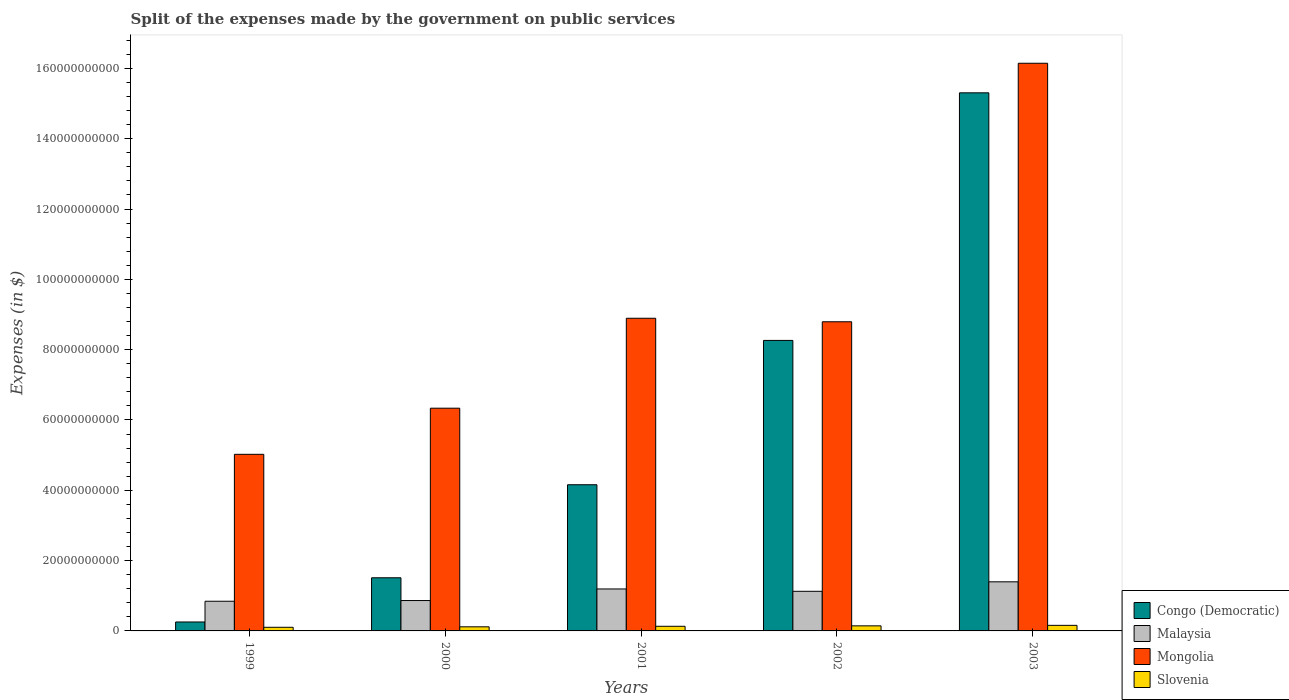How many different coloured bars are there?
Ensure brevity in your answer.  4. Are the number of bars per tick equal to the number of legend labels?
Keep it short and to the point. Yes. Are the number of bars on each tick of the X-axis equal?
Your answer should be very brief. Yes. How many bars are there on the 1st tick from the left?
Your answer should be very brief. 4. How many bars are there on the 1st tick from the right?
Ensure brevity in your answer.  4. What is the expenses made by the government on public services in Slovenia in 1999?
Offer a very short reply. 1.03e+09. Across all years, what is the maximum expenses made by the government on public services in Slovenia?
Keep it short and to the point. 1.58e+09. Across all years, what is the minimum expenses made by the government on public services in Congo (Democratic)?
Your answer should be compact. 2.54e+09. In which year was the expenses made by the government on public services in Slovenia maximum?
Offer a terse response. 2003. In which year was the expenses made by the government on public services in Congo (Democratic) minimum?
Offer a terse response. 1999. What is the total expenses made by the government on public services in Congo (Democratic) in the graph?
Your answer should be compact. 2.95e+11. What is the difference between the expenses made by the government on public services in Malaysia in 2002 and that in 2003?
Your response must be concise. -2.70e+09. What is the difference between the expenses made by the government on public services in Mongolia in 2000 and the expenses made by the government on public services in Slovenia in 2002?
Your response must be concise. 6.19e+1. What is the average expenses made by the government on public services in Slovenia per year?
Provide a succinct answer. 1.31e+09. In the year 1999, what is the difference between the expenses made by the government on public services in Malaysia and expenses made by the government on public services in Congo (Democratic)?
Offer a terse response. 5.90e+09. What is the ratio of the expenses made by the government on public services in Malaysia in 2002 to that in 2003?
Ensure brevity in your answer.  0.81. Is the expenses made by the government on public services in Malaysia in 1999 less than that in 2003?
Keep it short and to the point. Yes. Is the difference between the expenses made by the government on public services in Malaysia in 2000 and 2003 greater than the difference between the expenses made by the government on public services in Congo (Democratic) in 2000 and 2003?
Your response must be concise. Yes. What is the difference between the highest and the second highest expenses made by the government on public services in Malaysia?
Make the answer very short. 2.03e+09. What is the difference between the highest and the lowest expenses made by the government on public services in Mongolia?
Your response must be concise. 1.11e+11. In how many years, is the expenses made by the government on public services in Mongolia greater than the average expenses made by the government on public services in Mongolia taken over all years?
Offer a terse response. 1. What does the 4th bar from the left in 2002 represents?
Offer a very short reply. Slovenia. What does the 2nd bar from the right in 2003 represents?
Give a very brief answer. Mongolia. Is it the case that in every year, the sum of the expenses made by the government on public services in Malaysia and expenses made by the government on public services in Mongolia is greater than the expenses made by the government on public services in Slovenia?
Provide a short and direct response. Yes. How many bars are there?
Ensure brevity in your answer.  20. Are all the bars in the graph horizontal?
Your response must be concise. No. How many years are there in the graph?
Provide a short and direct response. 5. Does the graph contain any zero values?
Make the answer very short. No. Does the graph contain grids?
Make the answer very short. No. Where does the legend appear in the graph?
Offer a very short reply. Bottom right. How are the legend labels stacked?
Your answer should be very brief. Vertical. What is the title of the graph?
Ensure brevity in your answer.  Split of the expenses made by the government on public services. Does "Malta" appear as one of the legend labels in the graph?
Ensure brevity in your answer.  No. What is the label or title of the X-axis?
Provide a succinct answer. Years. What is the label or title of the Y-axis?
Offer a very short reply. Expenses (in $). What is the Expenses (in $) of Congo (Democratic) in 1999?
Ensure brevity in your answer.  2.54e+09. What is the Expenses (in $) in Malaysia in 1999?
Ensure brevity in your answer.  8.44e+09. What is the Expenses (in $) in Mongolia in 1999?
Your answer should be compact. 5.02e+1. What is the Expenses (in $) in Slovenia in 1999?
Your answer should be very brief. 1.03e+09. What is the Expenses (in $) of Congo (Democratic) in 2000?
Make the answer very short. 1.51e+1. What is the Expenses (in $) of Malaysia in 2000?
Provide a succinct answer. 8.64e+09. What is the Expenses (in $) of Mongolia in 2000?
Ensure brevity in your answer.  6.34e+1. What is the Expenses (in $) of Slovenia in 2000?
Ensure brevity in your answer.  1.17e+09. What is the Expenses (in $) in Congo (Democratic) in 2001?
Offer a terse response. 4.16e+1. What is the Expenses (in $) of Malaysia in 2001?
Your answer should be compact. 1.19e+1. What is the Expenses (in $) of Mongolia in 2001?
Keep it short and to the point. 8.89e+1. What is the Expenses (in $) of Slovenia in 2001?
Provide a succinct answer. 1.32e+09. What is the Expenses (in $) of Congo (Democratic) in 2002?
Your answer should be very brief. 8.26e+1. What is the Expenses (in $) in Malaysia in 2002?
Your answer should be very brief. 1.13e+1. What is the Expenses (in $) of Mongolia in 2002?
Your answer should be very brief. 8.79e+1. What is the Expenses (in $) of Slovenia in 2002?
Your answer should be compact. 1.44e+09. What is the Expenses (in $) of Congo (Democratic) in 2003?
Offer a very short reply. 1.53e+11. What is the Expenses (in $) in Malaysia in 2003?
Give a very brief answer. 1.40e+1. What is the Expenses (in $) in Mongolia in 2003?
Ensure brevity in your answer.  1.61e+11. What is the Expenses (in $) in Slovenia in 2003?
Offer a terse response. 1.58e+09. Across all years, what is the maximum Expenses (in $) of Congo (Democratic)?
Your answer should be very brief. 1.53e+11. Across all years, what is the maximum Expenses (in $) of Malaysia?
Your answer should be very brief. 1.40e+1. Across all years, what is the maximum Expenses (in $) in Mongolia?
Your answer should be very brief. 1.61e+11. Across all years, what is the maximum Expenses (in $) in Slovenia?
Your response must be concise. 1.58e+09. Across all years, what is the minimum Expenses (in $) in Congo (Democratic)?
Your answer should be compact. 2.54e+09. Across all years, what is the minimum Expenses (in $) of Malaysia?
Give a very brief answer. 8.44e+09. Across all years, what is the minimum Expenses (in $) in Mongolia?
Offer a very short reply. 5.02e+1. Across all years, what is the minimum Expenses (in $) in Slovenia?
Your answer should be very brief. 1.03e+09. What is the total Expenses (in $) in Congo (Democratic) in the graph?
Give a very brief answer. 2.95e+11. What is the total Expenses (in $) of Malaysia in the graph?
Ensure brevity in your answer.  5.43e+1. What is the total Expenses (in $) in Mongolia in the graph?
Your response must be concise. 4.52e+11. What is the total Expenses (in $) in Slovenia in the graph?
Your answer should be compact. 6.55e+09. What is the difference between the Expenses (in $) in Congo (Democratic) in 1999 and that in 2000?
Offer a terse response. -1.26e+1. What is the difference between the Expenses (in $) in Malaysia in 1999 and that in 2000?
Your response must be concise. -1.99e+08. What is the difference between the Expenses (in $) in Mongolia in 1999 and that in 2000?
Ensure brevity in your answer.  -1.31e+1. What is the difference between the Expenses (in $) of Slovenia in 1999 and that in 2000?
Your response must be concise. -1.32e+08. What is the difference between the Expenses (in $) in Congo (Democratic) in 1999 and that in 2001?
Your response must be concise. -3.90e+1. What is the difference between the Expenses (in $) of Malaysia in 1999 and that in 2001?
Offer a terse response. -3.49e+09. What is the difference between the Expenses (in $) in Mongolia in 1999 and that in 2001?
Offer a very short reply. -3.87e+1. What is the difference between the Expenses (in $) of Slovenia in 1999 and that in 2001?
Give a very brief answer. -2.86e+08. What is the difference between the Expenses (in $) of Congo (Democratic) in 1999 and that in 2002?
Your answer should be very brief. -8.01e+1. What is the difference between the Expenses (in $) in Malaysia in 1999 and that in 2002?
Your answer should be compact. -2.83e+09. What is the difference between the Expenses (in $) of Mongolia in 1999 and that in 2002?
Keep it short and to the point. -3.77e+1. What is the difference between the Expenses (in $) of Slovenia in 1999 and that in 2002?
Provide a succinct answer. -4.10e+08. What is the difference between the Expenses (in $) of Congo (Democratic) in 1999 and that in 2003?
Your answer should be compact. -1.51e+11. What is the difference between the Expenses (in $) in Malaysia in 1999 and that in 2003?
Ensure brevity in your answer.  -5.52e+09. What is the difference between the Expenses (in $) of Mongolia in 1999 and that in 2003?
Make the answer very short. -1.11e+11. What is the difference between the Expenses (in $) in Slovenia in 1999 and that in 2003?
Your answer should be very brief. -5.51e+08. What is the difference between the Expenses (in $) in Congo (Democratic) in 2000 and that in 2001?
Your response must be concise. -2.65e+1. What is the difference between the Expenses (in $) in Malaysia in 2000 and that in 2001?
Give a very brief answer. -3.29e+09. What is the difference between the Expenses (in $) of Mongolia in 2000 and that in 2001?
Offer a terse response. -2.56e+1. What is the difference between the Expenses (in $) of Slovenia in 2000 and that in 2001?
Make the answer very short. -1.53e+08. What is the difference between the Expenses (in $) of Congo (Democratic) in 2000 and that in 2002?
Provide a succinct answer. -6.75e+1. What is the difference between the Expenses (in $) in Malaysia in 2000 and that in 2002?
Offer a terse response. -2.63e+09. What is the difference between the Expenses (in $) in Mongolia in 2000 and that in 2002?
Give a very brief answer. -2.46e+1. What is the difference between the Expenses (in $) of Slovenia in 2000 and that in 2002?
Give a very brief answer. -2.78e+08. What is the difference between the Expenses (in $) in Congo (Democratic) in 2000 and that in 2003?
Provide a succinct answer. -1.38e+11. What is the difference between the Expenses (in $) in Malaysia in 2000 and that in 2003?
Provide a short and direct response. -5.33e+09. What is the difference between the Expenses (in $) of Mongolia in 2000 and that in 2003?
Provide a short and direct response. -9.81e+1. What is the difference between the Expenses (in $) of Slovenia in 2000 and that in 2003?
Provide a succinct answer. -4.19e+08. What is the difference between the Expenses (in $) in Congo (Democratic) in 2001 and that in 2002?
Your response must be concise. -4.11e+1. What is the difference between the Expenses (in $) of Malaysia in 2001 and that in 2002?
Give a very brief answer. 6.67e+08. What is the difference between the Expenses (in $) of Mongolia in 2001 and that in 2002?
Your answer should be very brief. 1.00e+09. What is the difference between the Expenses (in $) of Slovenia in 2001 and that in 2002?
Offer a terse response. -1.24e+08. What is the difference between the Expenses (in $) of Congo (Democratic) in 2001 and that in 2003?
Offer a terse response. -1.11e+11. What is the difference between the Expenses (in $) of Malaysia in 2001 and that in 2003?
Your answer should be very brief. -2.03e+09. What is the difference between the Expenses (in $) in Mongolia in 2001 and that in 2003?
Provide a short and direct response. -7.25e+1. What is the difference between the Expenses (in $) of Slovenia in 2001 and that in 2003?
Your answer should be very brief. -2.66e+08. What is the difference between the Expenses (in $) of Congo (Democratic) in 2002 and that in 2003?
Ensure brevity in your answer.  -7.04e+1. What is the difference between the Expenses (in $) in Malaysia in 2002 and that in 2003?
Provide a succinct answer. -2.70e+09. What is the difference between the Expenses (in $) in Mongolia in 2002 and that in 2003?
Offer a very short reply. -7.35e+1. What is the difference between the Expenses (in $) of Slovenia in 2002 and that in 2003?
Offer a terse response. -1.41e+08. What is the difference between the Expenses (in $) in Congo (Democratic) in 1999 and the Expenses (in $) in Malaysia in 2000?
Your answer should be compact. -6.10e+09. What is the difference between the Expenses (in $) of Congo (Democratic) in 1999 and the Expenses (in $) of Mongolia in 2000?
Your answer should be compact. -6.08e+1. What is the difference between the Expenses (in $) in Congo (Democratic) in 1999 and the Expenses (in $) in Slovenia in 2000?
Your answer should be very brief. 1.38e+09. What is the difference between the Expenses (in $) of Malaysia in 1999 and the Expenses (in $) of Mongolia in 2000?
Offer a very short reply. -5.49e+1. What is the difference between the Expenses (in $) in Malaysia in 1999 and the Expenses (in $) in Slovenia in 2000?
Give a very brief answer. 7.28e+09. What is the difference between the Expenses (in $) in Mongolia in 1999 and the Expenses (in $) in Slovenia in 2000?
Give a very brief answer. 4.91e+1. What is the difference between the Expenses (in $) of Congo (Democratic) in 1999 and the Expenses (in $) of Malaysia in 2001?
Keep it short and to the point. -9.39e+09. What is the difference between the Expenses (in $) in Congo (Democratic) in 1999 and the Expenses (in $) in Mongolia in 2001?
Offer a terse response. -8.64e+1. What is the difference between the Expenses (in $) in Congo (Democratic) in 1999 and the Expenses (in $) in Slovenia in 2001?
Provide a succinct answer. 1.22e+09. What is the difference between the Expenses (in $) of Malaysia in 1999 and the Expenses (in $) of Mongolia in 2001?
Ensure brevity in your answer.  -8.05e+1. What is the difference between the Expenses (in $) in Malaysia in 1999 and the Expenses (in $) in Slovenia in 2001?
Provide a short and direct response. 7.12e+09. What is the difference between the Expenses (in $) in Mongolia in 1999 and the Expenses (in $) in Slovenia in 2001?
Your answer should be compact. 4.89e+1. What is the difference between the Expenses (in $) of Congo (Democratic) in 1999 and the Expenses (in $) of Malaysia in 2002?
Ensure brevity in your answer.  -8.73e+09. What is the difference between the Expenses (in $) of Congo (Democratic) in 1999 and the Expenses (in $) of Mongolia in 2002?
Your answer should be very brief. -8.54e+1. What is the difference between the Expenses (in $) in Congo (Democratic) in 1999 and the Expenses (in $) in Slovenia in 2002?
Provide a short and direct response. 1.10e+09. What is the difference between the Expenses (in $) of Malaysia in 1999 and the Expenses (in $) of Mongolia in 2002?
Your response must be concise. -7.95e+1. What is the difference between the Expenses (in $) in Malaysia in 1999 and the Expenses (in $) in Slovenia in 2002?
Your response must be concise. 7.00e+09. What is the difference between the Expenses (in $) of Mongolia in 1999 and the Expenses (in $) of Slovenia in 2002?
Your answer should be compact. 4.88e+1. What is the difference between the Expenses (in $) of Congo (Democratic) in 1999 and the Expenses (in $) of Malaysia in 2003?
Ensure brevity in your answer.  -1.14e+1. What is the difference between the Expenses (in $) of Congo (Democratic) in 1999 and the Expenses (in $) of Mongolia in 2003?
Give a very brief answer. -1.59e+11. What is the difference between the Expenses (in $) of Congo (Democratic) in 1999 and the Expenses (in $) of Slovenia in 2003?
Make the answer very short. 9.58e+08. What is the difference between the Expenses (in $) in Malaysia in 1999 and the Expenses (in $) in Mongolia in 2003?
Provide a short and direct response. -1.53e+11. What is the difference between the Expenses (in $) of Malaysia in 1999 and the Expenses (in $) of Slovenia in 2003?
Your response must be concise. 6.86e+09. What is the difference between the Expenses (in $) of Mongolia in 1999 and the Expenses (in $) of Slovenia in 2003?
Offer a very short reply. 4.86e+1. What is the difference between the Expenses (in $) in Congo (Democratic) in 2000 and the Expenses (in $) in Malaysia in 2001?
Offer a very short reply. 3.18e+09. What is the difference between the Expenses (in $) in Congo (Democratic) in 2000 and the Expenses (in $) in Mongolia in 2001?
Your answer should be compact. -7.38e+1. What is the difference between the Expenses (in $) in Congo (Democratic) in 2000 and the Expenses (in $) in Slovenia in 2001?
Keep it short and to the point. 1.38e+1. What is the difference between the Expenses (in $) of Malaysia in 2000 and the Expenses (in $) of Mongolia in 2001?
Keep it short and to the point. -8.03e+1. What is the difference between the Expenses (in $) in Malaysia in 2000 and the Expenses (in $) in Slovenia in 2001?
Make the answer very short. 7.32e+09. What is the difference between the Expenses (in $) in Mongolia in 2000 and the Expenses (in $) in Slovenia in 2001?
Ensure brevity in your answer.  6.20e+1. What is the difference between the Expenses (in $) in Congo (Democratic) in 2000 and the Expenses (in $) in Malaysia in 2002?
Your answer should be very brief. 3.85e+09. What is the difference between the Expenses (in $) of Congo (Democratic) in 2000 and the Expenses (in $) of Mongolia in 2002?
Keep it short and to the point. -7.28e+1. What is the difference between the Expenses (in $) in Congo (Democratic) in 2000 and the Expenses (in $) in Slovenia in 2002?
Make the answer very short. 1.37e+1. What is the difference between the Expenses (in $) in Malaysia in 2000 and the Expenses (in $) in Mongolia in 2002?
Your answer should be very brief. -7.93e+1. What is the difference between the Expenses (in $) of Malaysia in 2000 and the Expenses (in $) of Slovenia in 2002?
Your response must be concise. 7.20e+09. What is the difference between the Expenses (in $) in Mongolia in 2000 and the Expenses (in $) in Slovenia in 2002?
Make the answer very short. 6.19e+1. What is the difference between the Expenses (in $) of Congo (Democratic) in 2000 and the Expenses (in $) of Malaysia in 2003?
Your answer should be compact. 1.15e+09. What is the difference between the Expenses (in $) in Congo (Democratic) in 2000 and the Expenses (in $) in Mongolia in 2003?
Provide a short and direct response. -1.46e+11. What is the difference between the Expenses (in $) of Congo (Democratic) in 2000 and the Expenses (in $) of Slovenia in 2003?
Your response must be concise. 1.35e+1. What is the difference between the Expenses (in $) of Malaysia in 2000 and the Expenses (in $) of Mongolia in 2003?
Offer a very short reply. -1.53e+11. What is the difference between the Expenses (in $) in Malaysia in 2000 and the Expenses (in $) in Slovenia in 2003?
Your answer should be compact. 7.06e+09. What is the difference between the Expenses (in $) of Mongolia in 2000 and the Expenses (in $) of Slovenia in 2003?
Give a very brief answer. 6.18e+1. What is the difference between the Expenses (in $) of Congo (Democratic) in 2001 and the Expenses (in $) of Malaysia in 2002?
Your answer should be very brief. 3.03e+1. What is the difference between the Expenses (in $) of Congo (Democratic) in 2001 and the Expenses (in $) of Mongolia in 2002?
Your response must be concise. -4.64e+1. What is the difference between the Expenses (in $) in Congo (Democratic) in 2001 and the Expenses (in $) in Slovenia in 2002?
Your answer should be very brief. 4.01e+1. What is the difference between the Expenses (in $) in Malaysia in 2001 and the Expenses (in $) in Mongolia in 2002?
Provide a short and direct response. -7.60e+1. What is the difference between the Expenses (in $) of Malaysia in 2001 and the Expenses (in $) of Slovenia in 2002?
Provide a short and direct response. 1.05e+1. What is the difference between the Expenses (in $) in Mongolia in 2001 and the Expenses (in $) in Slovenia in 2002?
Ensure brevity in your answer.  8.75e+1. What is the difference between the Expenses (in $) of Congo (Democratic) in 2001 and the Expenses (in $) of Malaysia in 2003?
Your answer should be very brief. 2.76e+1. What is the difference between the Expenses (in $) in Congo (Democratic) in 2001 and the Expenses (in $) in Mongolia in 2003?
Give a very brief answer. -1.20e+11. What is the difference between the Expenses (in $) in Congo (Democratic) in 2001 and the Expenses (in $) in Slovenia in 2003?
Your response must be concise. 4.00e+1. What is the difference between the Expenses (in $) of Malaysia in 2001 and the Expenses (in $) of Mongolia in 2003?
Provide a succinct answer. -1.50e+11. What is the difference between the Expenses (in $) of Malaysia in 2001 and the Expenses (in $) of Slovenia in 2003?
Make the answer very short. 1.04e+1. What is the difference between the Expenses (in $) of Mongolia in 2001 and the Expenses (in $) of Slovenia in 2003?
Keep it short and to the point. 8.73e+1. What is the difference between the Expenses (in $) in Congo (Democratic) in 2002 and the Expenses (in $) in Malaysia in 2003?
Offer a very short reply. 6.87e+1. What is the difference between the Expenses (in $) in Congo (Democratic) in 2002 and the Expenses (in $) in Mongolia in 2003?
Your response must be concise. -7.88e+1. What is the difference between the Expenses (in $) of Congo (Democratic) in 2002 and the Expenses (in $) of Slovenia in 2003?
Offer a very short reply. 8.10e+1. What is the difference between the Expenses (in $) of Malaysia in 2002 and the Expenses (in $) of Mongolia in 2003?
Give a very brief answer. -1.50e+11. What is the difference between the Expenses (in $) in Malaysia in 2002 and the Expenses (in $) in Slovenia in 2003?
Your answer should be very brief. 9.68e+09. What is the difference between the Expenses (in $) of Mongolia in 2002 and the Expenses (in $) of Slovenia in 2003?
Keep it short and to the point. 8.63e+1. What is the average Expenses (in $) of Congo (Democratic) per year?
Ensure brevity in your answer.  5.90e+1. What is the average Expenses (in $) in Malaysia per year?
Ensure brevity in your answer.  1.09e+1. What is the average Expenses (in $) in Mongolia per year?
Provide a succinct answer. 9.04e+1. What is the average Expenses (in $) of Slovenia per year?
Make the answer very short. 1.31e+09. In the year 1999, what is the difference between the Expenses (in $) of Congo (Democratic) and Expenses (in $) of Malaysia?
Provide a succinct answer. -5.90e+09. In the year 1999, what is the difference between the Expenses (in $) in Congo (Democratic) and Expenses (in $) in Mongolia?
Provide a short and direct response. -4.77e+1. In the year 1999, what is the difference between the Expenses (in $) of Congo (Democratic) and Expenses (in $) of Slovenia?
Your answer should be very brief. 1.51e+09. In the year 1999, what is the difference between the Expenses (in $) in Malaysia and Expenses (in $) in Mongolia?
Ensure brevity in your answer.  -4.18e+1. In the year 1999, what is the difference between the Expenses (in $) in Malaysia and Expenses (in $) in Slovenia?
Keep it short and to the point. 7.41e+09. In the year 1999, what is the difference between the Expenses (in $) of Mongolia and Expenses (in $) of Slovenia?
Provide a short and direct response. 4.92e+1. In the year 2000, what is the difference between the Expenses (in $) in Congo (Democratic) and Expenses (in $) in Malaysia?
Offer a terse response. 6.48e+09. In the year 2000, what is the difference between the Expenses (in $) in Congo (Democratic) and Expenses (in $) in Mongolia?
Make the answer very short. -4.82e+1. In the year 2000, what is the difference between the Expenses (in $) of Congo (Democratic) and Expenses (in $) of Slovenia?
Your response must be concise. 1.40e+1. In the year 2000, what is the difference between the Expenses (in $) of Malaysia and Expenses (in $) of Mongolia?
Keep it short and to the point. -5.47e+1. In the year 2000, what is the difference between the Expenses (in $) of Malaysia and Expenses (in $) of Slovenia?
Keep it short and to the point. 7.48e+09. In the year 2000, what is the difference between the Expenses (in $) of Mongolia and Expenses (in $) of Slovenia?
Keep it short and to the point. 6.22e+1. In the year 2001, what is the difference between the Expenses (in $) in Congo (Democratic) and Expenses (in $) in Malaysia?
Ensure brevity in your answer.  2.96e+1. In the year 2001, what is the difference between the Expenses (in $) of Congo (Democratic) and Expenses (in $) of Mongolia?
Offer a terse response. -4.74e+1. In the year 2001, what is the difference between the Expenses (in $) of Congo (Democratic) and Expenses (in $) of Slovenia?
Offer a very short reply. 4.03e+1. In the year 2001, what is the difference between the Expenses (in $) of Malaysia and Expenses (in $) of Mongolia?
Offer a very short reply. -7.70e+1. In the year 2001, what is the difference between the Expenses (in $) of Malaysia and Expenses (in $) of Slovenia?
Keep it short and to the point. 1.06e+1. In the year 2001, what is the difference between the Expenses (in $) of Mongolia and Expenses (in $) of Slovenia?
Keep it short and to the point. 8.76e+1. In the year 2002, what is the difference between the Expenses (in $) of Congo (Democratic) and Expenses (in $) of Malaysia?
Provide a succinct answer. 7.14e+1. In the year 2002, what is the difference between the Expenses (in $) of Congo (Democratic) and Expenses (in $) of Mongolia?
Give a very brief answer. -5.30e+09. In the year 2002, what is the difference between the Expenses (in $) of Congo (Democratic) and Expenses (in $) of Slovenia?
Your response must be concise. 8.12e+1. In the year 2002, what is the difference between the Expenses (in $) in Malaysia and Expenses (in $) in Mongolia?
Your answer should be very brief. -7.67e+1. In the year 2002, what is the difference between the Expenses (in $) in Malaysia and Expenses (in $) in Slovenia?
Provide a succinct answer. 9.83e+09. In the year 2002, what is the difference between the Expenses (in $) in Mongolia and Expenses (in $) in Slovenia?
Provide a succinct answer. 8.65e+1. In the year 2003, what is the difference between the Expenses (in $) of Congo (Democratic) and Expenses (in $) of Malaysia?
Your response must be concise. 1.39e+11. In the year 2003, what is the difference between the Expenses (in $) of Congo (Democratic) and Expenses (in $) of Mongolia?
Provide a succinct answer. -8.41e+09. In the year 2003, what is the difference between the Expenses (in $) in Congo (Democratic) and Expenses (in $) in Slovenia?
Provide a short and direct response. 1.51e+11. In the year 2003, what is the difference between the Expenses (in $) of Malaysia and Expenses (in $) of Mongolia?
Your answer should be compact. -1.47e+11. In the year 2003, what is the difference between the Expenses (in $) of Malaysia and Expenses (in $) of Slovenia?
Provide a succinct answer. 1.24e+1. In the year 2003, what is the difference between the Expenses (in $) in Mongolia and Expenses (in $) in Slovenia?
Your answer should be very brief. 1.60e+11. What is the ratio of the Expenses (in $) of Congo (Democratic) in 1999 to that in 2000?
Ensure brevity in your answer.  0.17. What is the ratio of the Expenses (in $) of Mongolia in 1999 to that in 2000?
Offer a very short reply. 0.79. What is the ratio of the Expenses (in $) of Slovenia in 1999 to that in 2000?
Your response must be concise. 0.89. What is the ratio of the Expenses (in $) of Congo (Democratic) in 1999 to that in 2001?
Give a very brief answer. 0.06. What is the ratio of the Expenses (in $) of Malaysia in 1999 to that in 2001?
Give a very brief answer. 0.71. What is the ratio of the Expenses (in $) of Mongolia in 1999 to that in 2001?
Your answer should be very brief. 0.56. What is the ratio of the Expenses (in $) of Slovenia in 1999 to that in 2001?
Offer a very short reply. 0.78. What is the ratio of the Expenses (in $) in Congo (Democratic) in 1999 to that in 2002?
Provide a short and direct response. 0.03. What is the ratio of the Expenses (in $) in Malaysia in 1999 to that in 2002?
Give a very brief answer. 0.75. What is the ratio of the Expenses (in $) in Mongolia in 1999 to that in 2002?
Offer a very short reply. 0.57. What is the ratio of the Expenses (in $) of Slovenia in 1999 to that in 2002?
Your answer should be compact. 0.72. What is the ratio of the Expenses (in $) in Congo (Democratic) in 1999 to that in 2003?
Offer a terse response. 0.02. What is the ratio of the Expenses (in $) in Malaysia in 1999 to that in 2003?
Provide a short and direct response. 0.6. What is the ratio of the Expenses (in $) of Mongolia in 1999 to that in 2003?
Keep it short and to the point. 0.31. What is the ratio of the Expenses (in $) of Slovenia in 1999 to that in 2003?
Give a very brief answer. 0.65. What is the ratio of the Expenses (in $) in Congo (Democratic) in 2000 to that in 2001?
Your response must be concise. 0.36. What is the ratio of the Expenses (in $) of Malaysia in 2000 to that in 2001?
Your answer should be compact. 0.72. What is the ratio of the Expenses (in $) in Mongolia in 2000 to that in 2001?
Ensure brevity in your answer.  0.71. What is the ratio of the Expenses (in $) of Slovenia in 2000 to that in 2001?
Keep it short and to the point. 0.88. What is the ratio of the Expenses (in $) of Congo (Democratic) in 2000 to that in 2002?
Your answer should be very brief. 0.18. What is the ratio of the Expenses (in $) of Malaysia in 2000 to that in 2002?
Provide a short and direct response. 0.77. What is the ratio of the Expenses (in $) of Mongolia in 2000 to that in 2002?
Ensure brevity in your answer.  0.72. What is the ratio of the Expenses (in $) in Slovenia in 2000 to that in 2002?
Provide a succinct answer. 0.81. What is the ratio of the Expenses (in $) of Congo (Democratic) in 2000 to that in 2003?
Your answer should be compact. 0.1. What is the ratio of the Expenses (in $) in Malaysia in 2000 to that in 2003?
Your response must be concise. 0.62. What is the ratio of the Expenses (in $) of Mongolia in 2000 to that in 2003?
Keep it short and to the point. 0.39. What is the ratio of the Expenses (in $) of Slovenia in 2000 to that in 2003?
Your answer should be very brief. 0.74. What is the ratio of the Expenses (in $) in Congo (Democratic) in 2001 to that in 2002?
Provide a short and direct response. 0.5. What is the ratio of the Expenses (in $) in Malaysia in 2001 to that in 2002?
Provide a short and direct response. 1.06. What is the ratio of the Expenses (in $) of Mongolia in 2001 to that in 2002?
Your answer should be very brief. 1.01. What is the ratio of the Expenses (in $) in Slovenia in 2001 to that in 2002?
Your response must be concise. 0.91. What is the ratio of the Expenses (in $) of Congo (Democratic) in 2001 to that in 2003?
Your response must be concise. 0.27. What is the ratio of the Expenses (in $) of Malaysia in 2001 to that in 2003?
Ensure brevity in your answer.  0.85. What is the ratio of the Expenses (in $) in Mongolia in 2001 to that in 2003?
Ensure brevity in your answer.  0.55. What is the ratio of the Expenses (in $) in Slovenia in 2001 to that in 2003?
Give a very brief answer. 0.83. What is the ratio of the Expenses (in $) of Congo (Democratic) in 2002 to that in 2003?
Keep it short and to the point. 0.54. What is the ratio of the Expenses (in $) in Malaysia in 2002 to that in 2003?
Your answer should be very brief. 0.81. What is the ratio of the Expenses (in $) in Mongolia in 2002 to that in 2003?
Your response must be concise. 0.54. What is the ratio of the Expenses (in $) in Slovenia in 2002 to that in 2003?
Keep it short and to the point. 0.91. What is the difference between the highest and the second highest Expenses (in $) in Congo (Democratic)?
Your response must be concise. 7.04e+1. What is the difference between the highest and the second highest Expenses (in $) in Malaysia?
Make the answer very short. 2.03e+09. What is the difference between the highest and the second highest Expenses (in $) of Mongolia?
Your response must be concise. 7.25e+1. What is the difference between the highest and the second highest Expenses (in $) in Slovenia?
Provide a succinct answer. 1.41e+08. What is the difference between the highest and the lowest Expenses (in $) of Congo (Democratic)?
Offer a terse response. 1.51e+11. What is the difference between the highest and the lowest Expenses (in $) in Malaysia?
Offer a terse response. 5.52e+09. What is the difference between the highest and the lowest Expenses (in $) of Mongolia?
Provide a succinct answer. 1.11e+11. What is the difference between the highest and the lowest Expenses (in $) of Slovenia?
Offer a very short reply. 5.51e+08. 